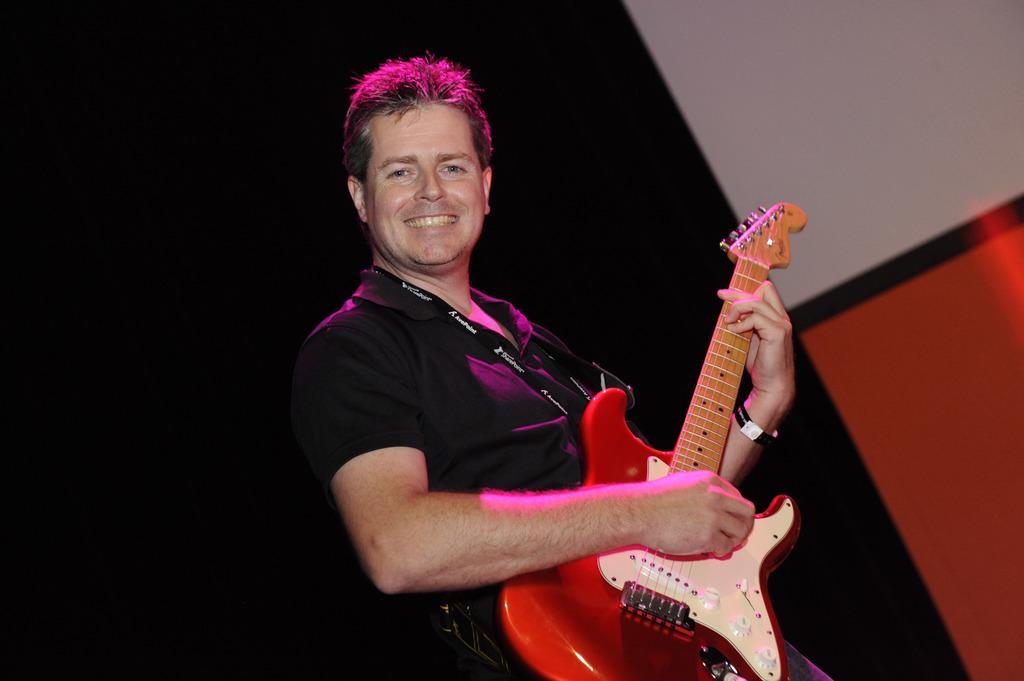Please provide a concise description of this image. In the center of the image we can see a man standing and holding a guitar. In the background there is a wall. 